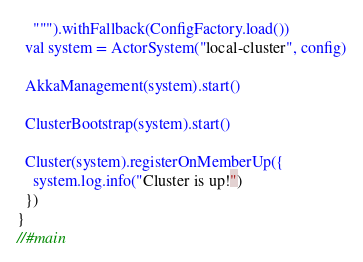<code> <loc_0><loc_0><loc_500><loc_500><_Scala_>    """).withFallback(ConfigFactory.load())
  val system = ActorSystem("local-cluster", config)

  AkkaManagement(system).start()

  ClusterBootstrap(system).start()

  Cluster(system).registerOnMemberUp({
    system.log.info("Cluster is up!")
  })
}
//#main
</code> 